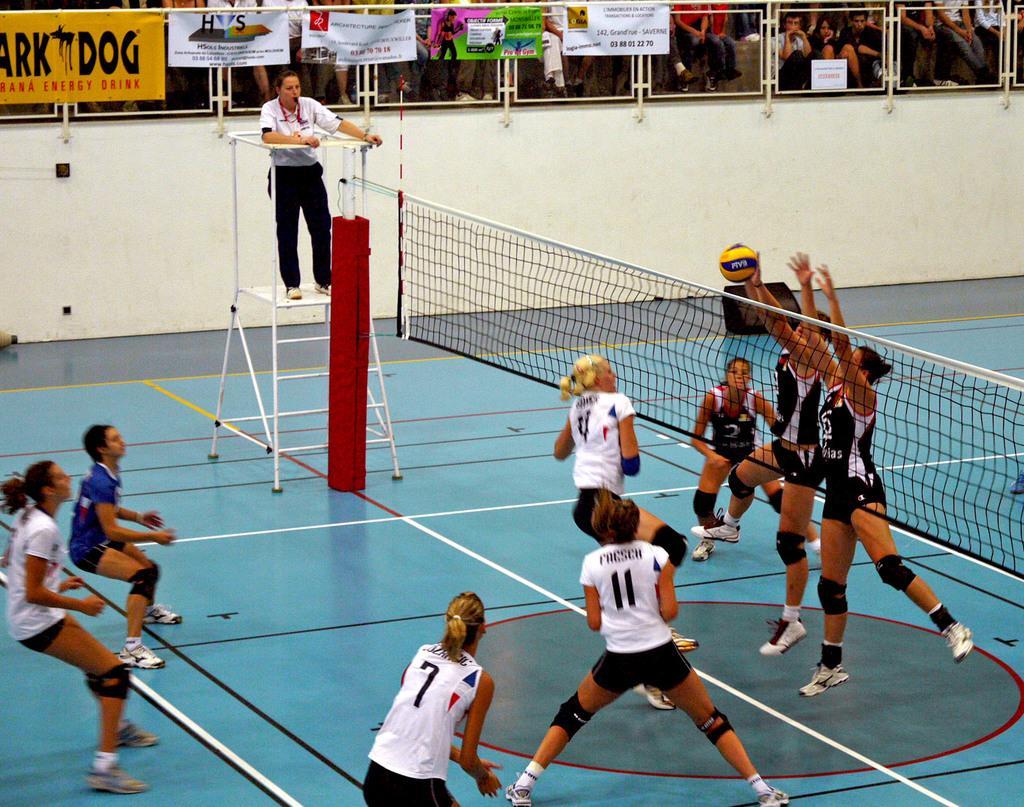Please provide a concise description of this image. In this image we can see the players playing. We can also see the netball, court, wall and also the banners. We can also see the railing. There is a person standing on the ladder. We can also see the people. 